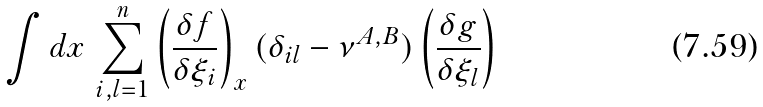Convert formula to latex. <formula><loc_0><loc_0><loc_500><loc_500>\int d x \, \sum _ { i , l = 1 } ^ { n } \left ( \frac { \delta f } { \delta \xi _ { i } } \right ) _ { x } ( \delta _ { i l } - \nu ^ { A , B } ) \left ( \frac { \delta g } { \delta \xi _ { l } } \right )</formula> 